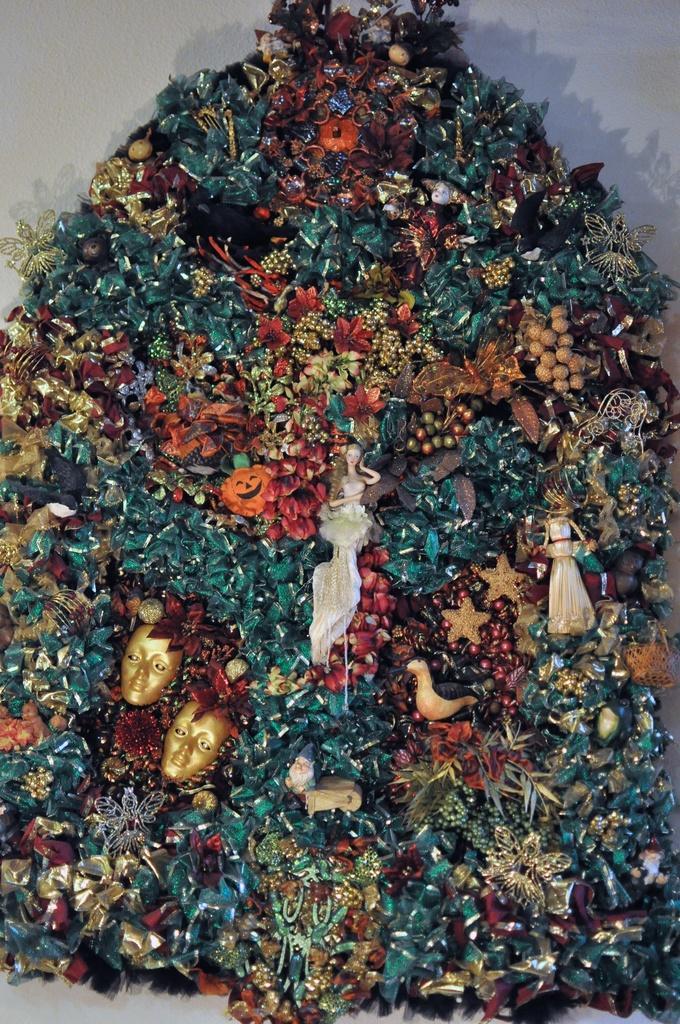In one or two sentences, can you explain what this image depicts? There are some decorative items in the image. 